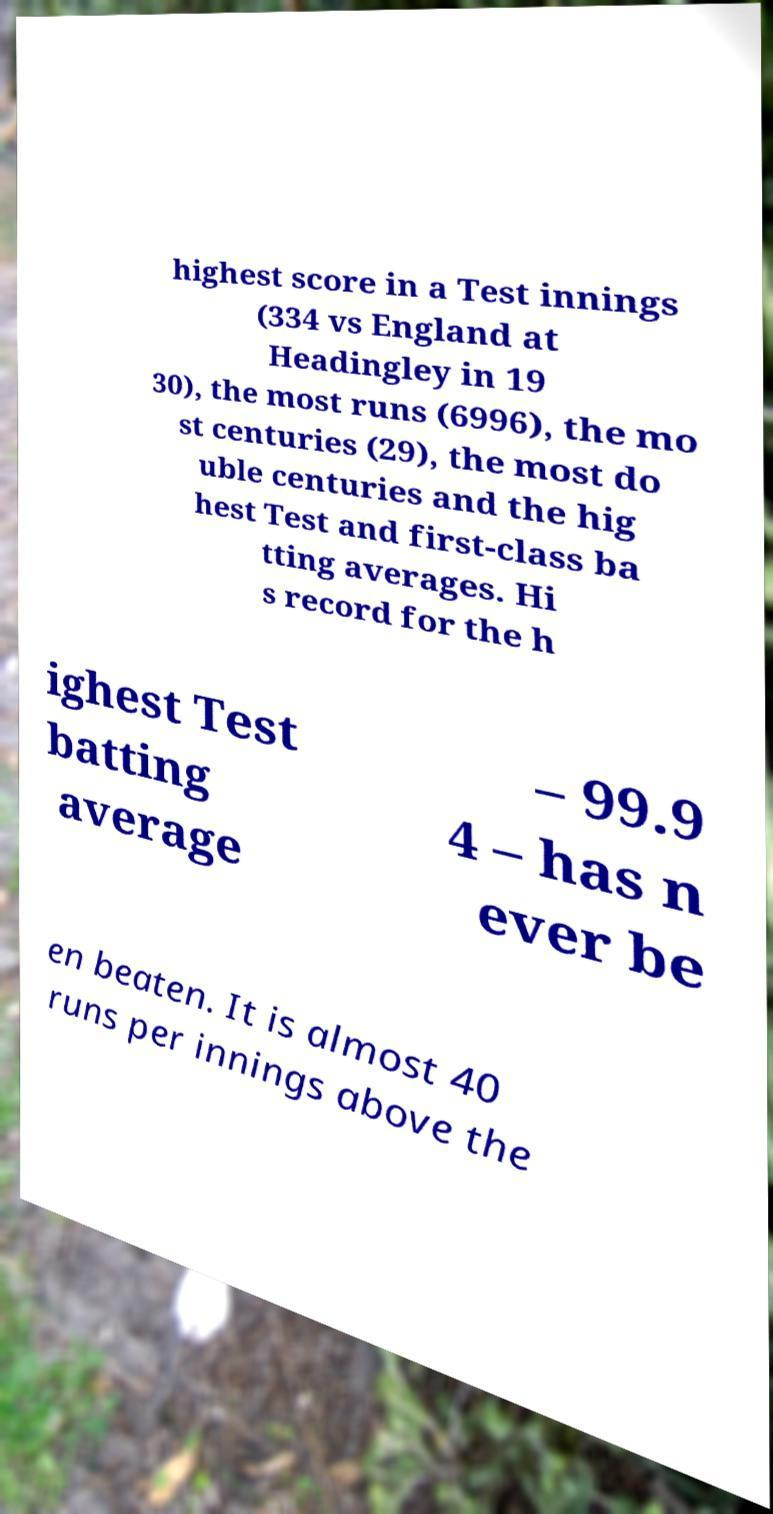Please read and relay the text visible in this image. What does it say? highest score in a Test innings (334 vs England at Headingley in 19 30), the most runs (6996), the mo st centuries (29), the most do uble centuries and the hig hest Test and first-class ba tting averages. Hi s record for the h ighest Test batting average – 99.9 4 – has n ever be en beaten. It is almost 40 runs per innings above the 